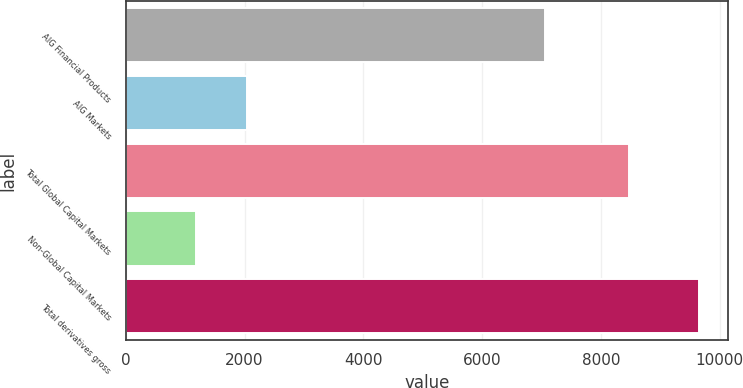Convert chart. <chart><loc_0><loc_0><loc_500><loc_500><bar_chart><fcel>AIG Financial Products<fcel>AIG Markets<fcel>Total Global Capital Markets<fcel>Non-Global Capital Markets<fcel>Total derivatives gross<nl><fcel>7063<fcel>2035.2<fcel>8472<fcel>1188<fcel>9660<nl></chart> 